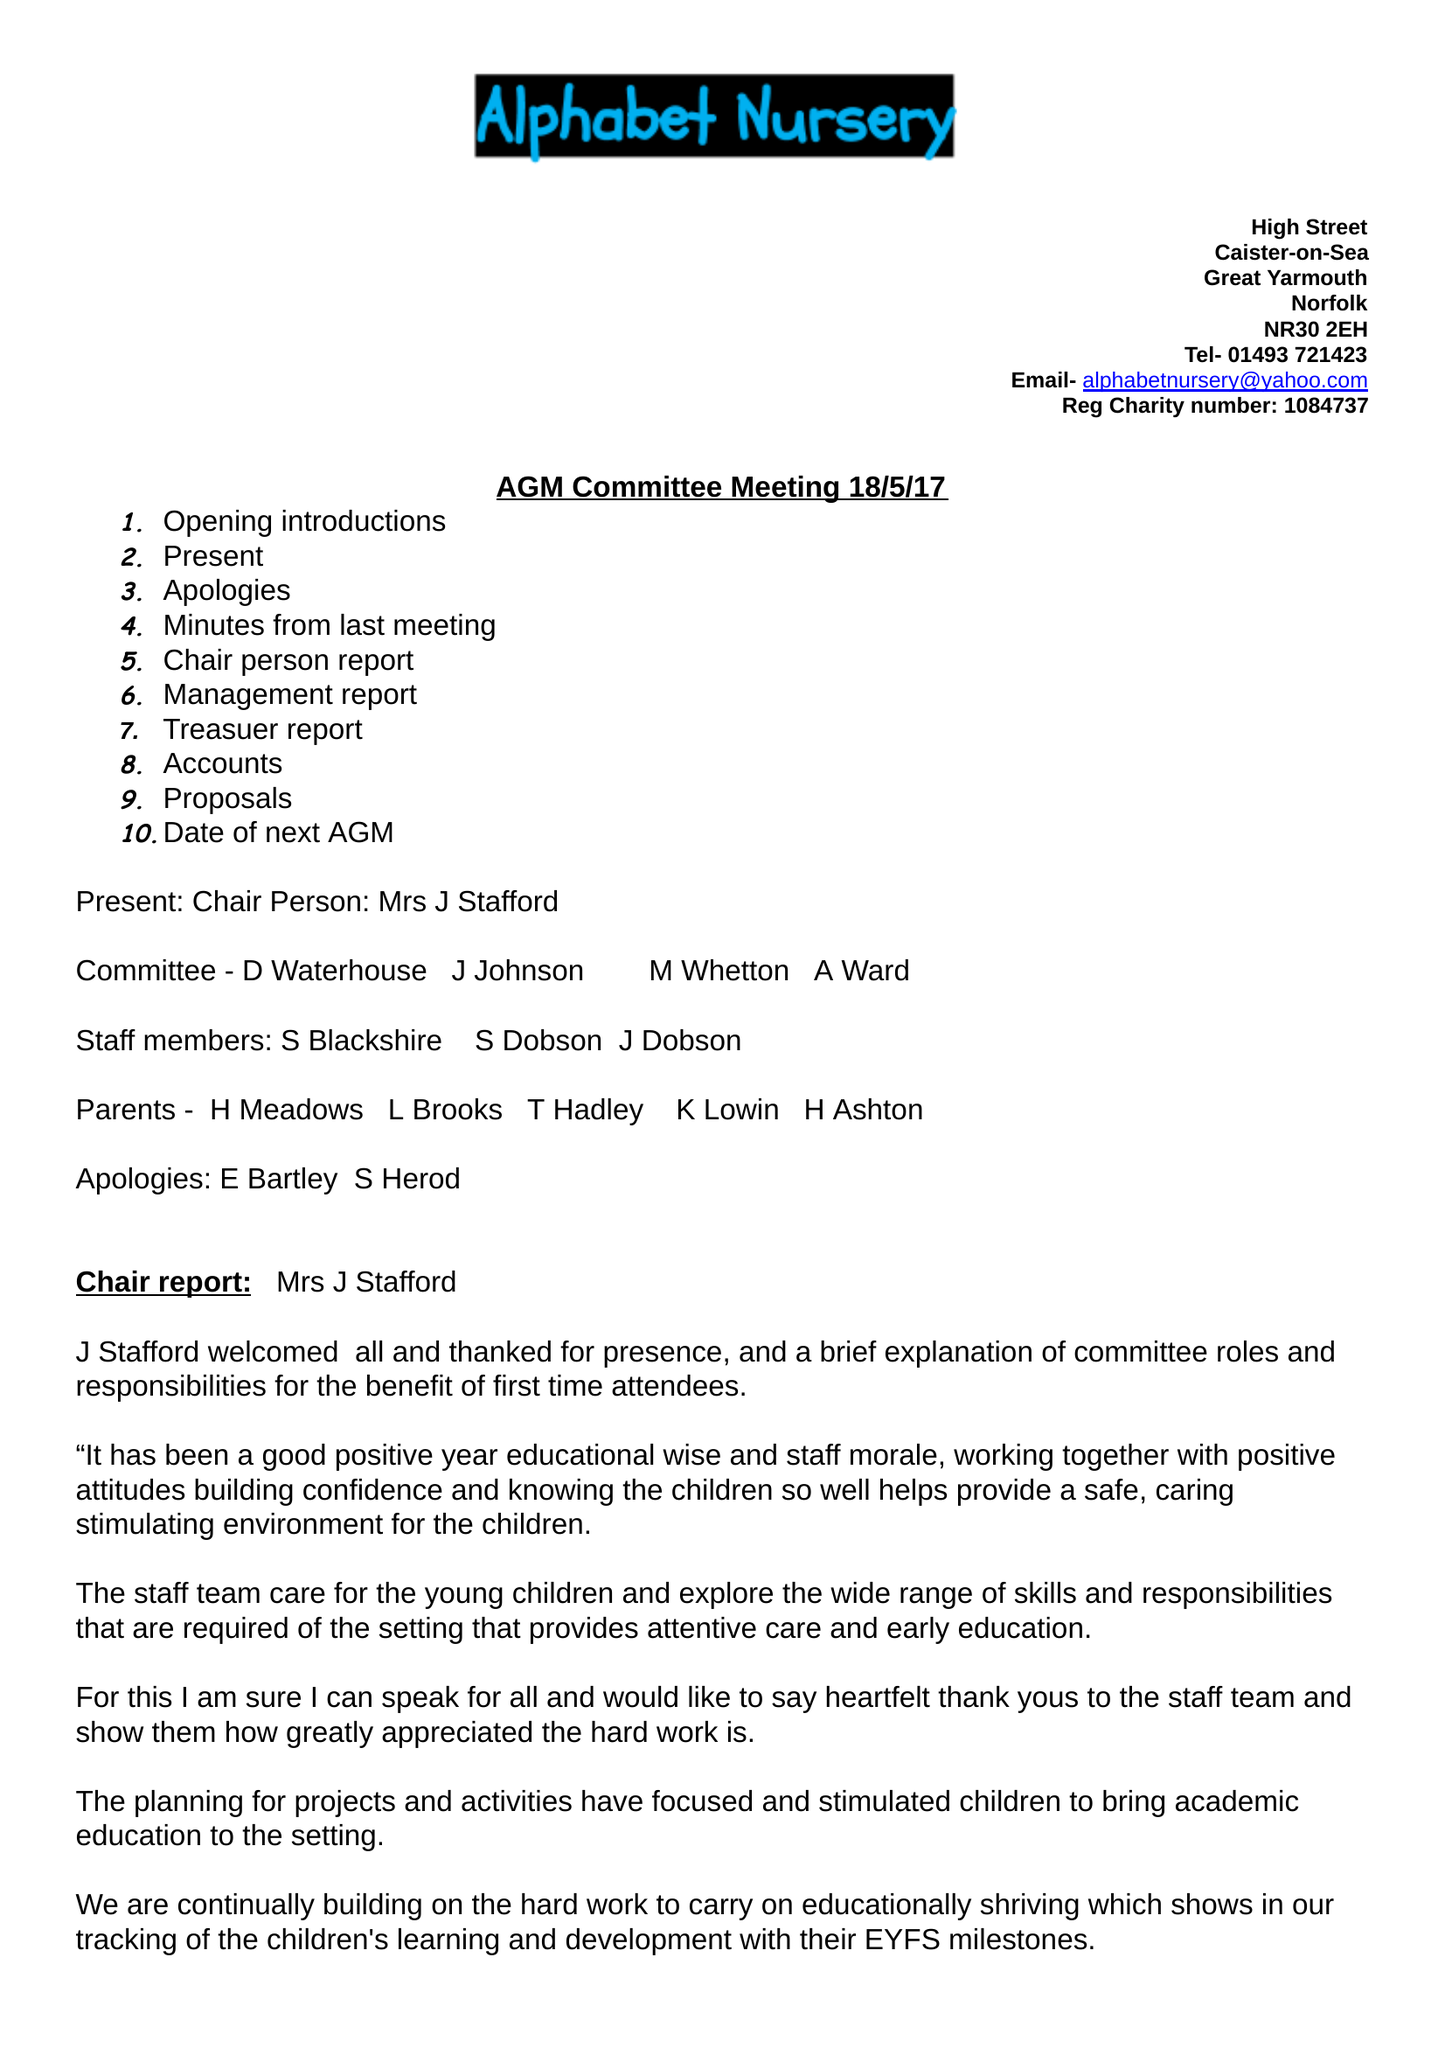What is the value for the spending_annually_in_british_pounds?
Answer the question using a single word or phrase. 42030.00 